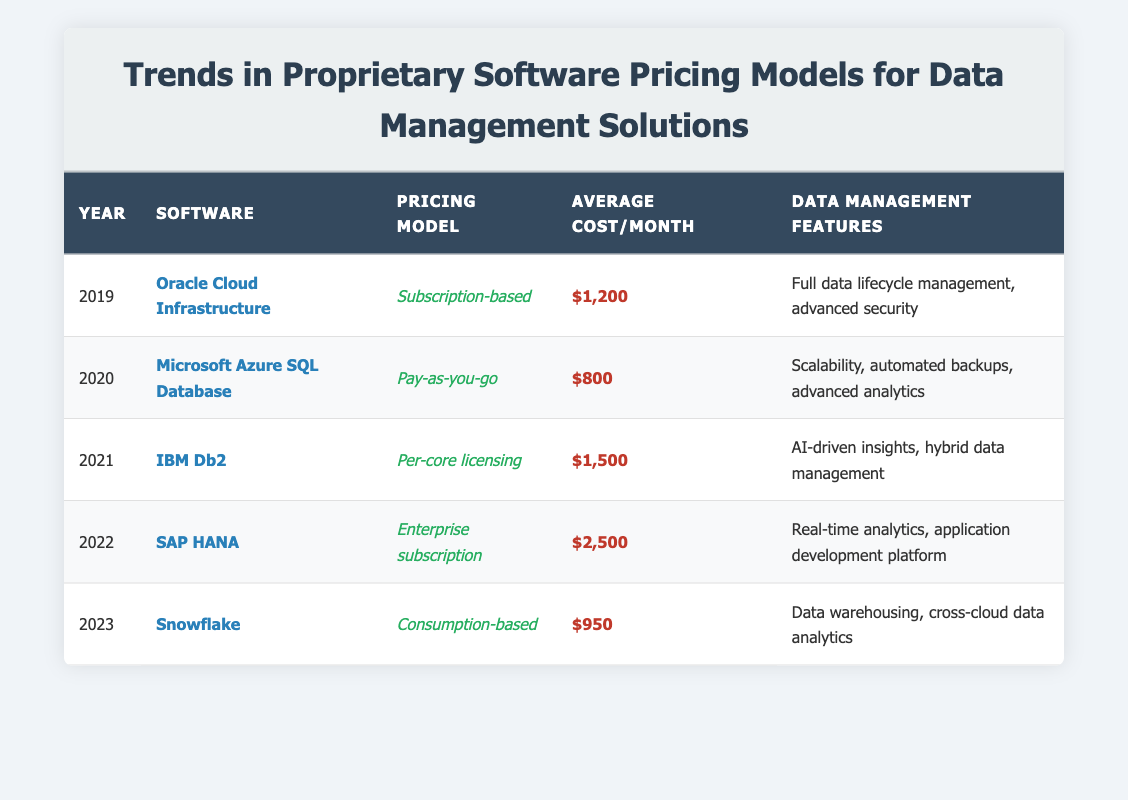What is the pricing model for SAP HANA? Referring to the table, the row corresponding to SAP HANA indicates that the pricing model is "Enterprise subscription."
Answer: Enterprise subscription Which software was priced the highest in 2022? The table shows that the software with the highest average cost per month in 2022 is SAP HANA, which costs $2,500.
Answer: SAP HANA How much did the average cost per month increase from 2019 to 2022? The average cost per month in 2019 was $1,200 and in 2022 it was $2,500. The increase is calculated as $2,500 - $1,200 = $1,300.
Answer: $1,300 Is the average cost per month of Snowflake lower than that of Microsoft Azure SQL Database? The average cost for Snowflake in 2023 is $950, while Microsoft Azure SQL Database in 2020 is $800. Since $950 is greater than $800, the statement is false.
Answer: No What is the average cost per month of all the software listed in the table? The average is calculated by summing the individual monthly costs: $1,200 + $800 + $1,500 + $2,500 + $950 = $7,950. There are 5 software solutions, so the average cost is $7,950 / 5 = $1,590.
Answer: $1,590 Which pricing model was used for IBM Db2 in 2021? By looking at the row for IBM Db2 in the table, the pricing model is indicated as "Per-core licensing."
Answer: Per-core licensing Did any software switch to a consumption-based pricing model from a subscription-based model in these five years? The data shows that Oracle Cloud Infrastructure used a subscription-based model in 2019, while Snowflake switched to a consumption-based model in 2023, indicating a shift from subscription to consumption-based pricing.
Answer: Yes What features are offered by Microsoft Azure SQL Database? The table lists the data management features for Microsoft Azure SQL Database as "Scalability, automated backups, advanced analytics."
Answer: Scalability, automated backups, advanced analytics 